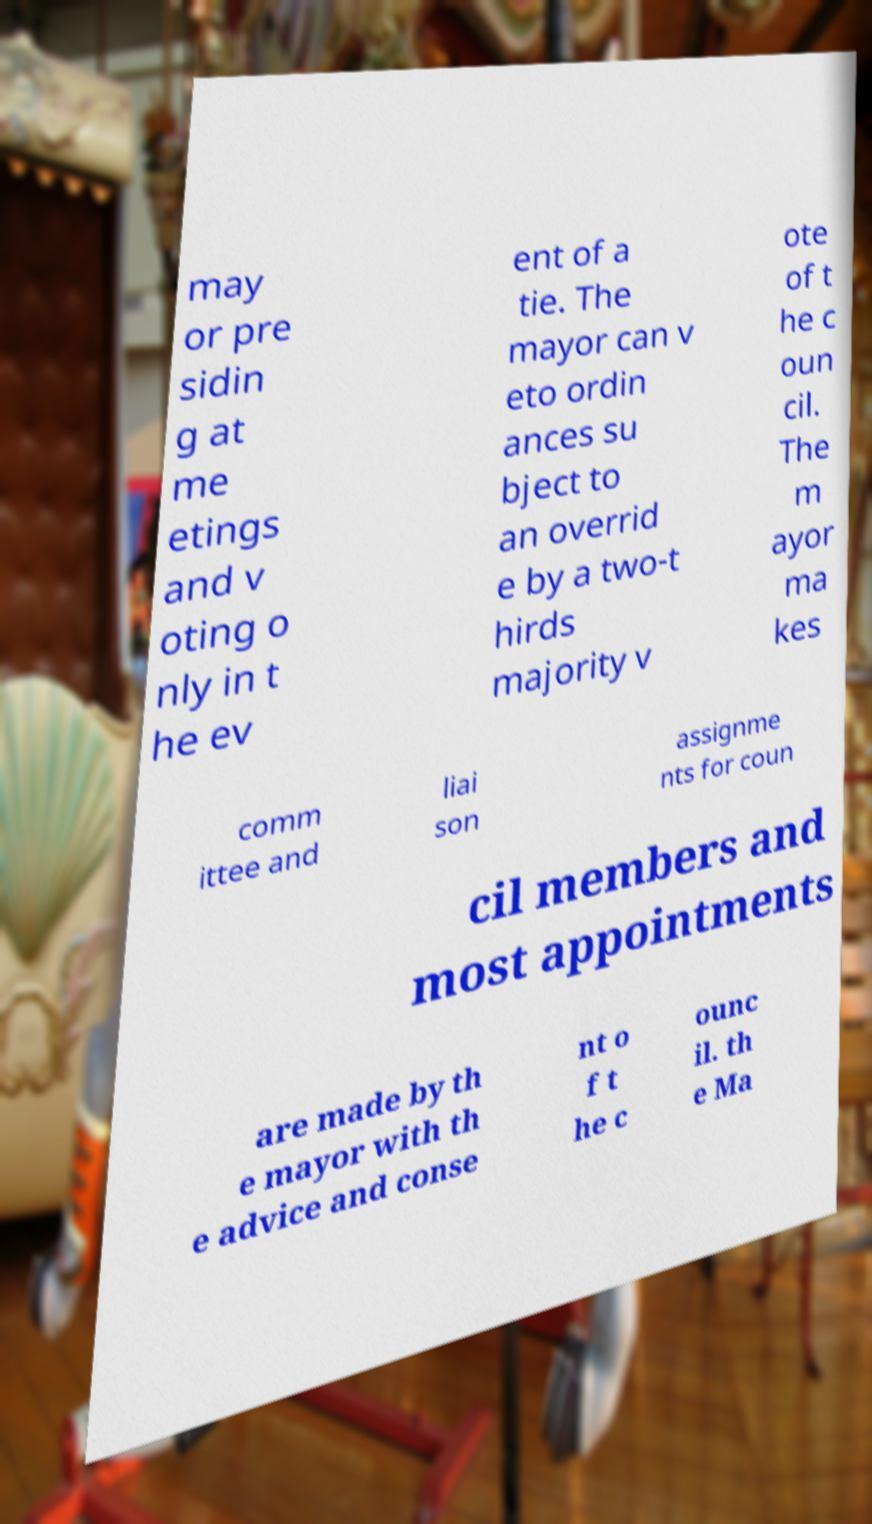For documentation purposes, I need the text within this image transcribed. Could you provide that? may or pre sidin g at me etings and v oting o nly in t he ev ent of a tie. The mayor can v eto ordin ances su bject to an overrid e by a two-t hirds majority v ote of t he c oun cil. The m ayor ma kes comm ittee and liai son assignme nts for coun cil members and most appointments are made by th e mayor with th e advice and conse nt o f t he c ounc il. th e Ma 